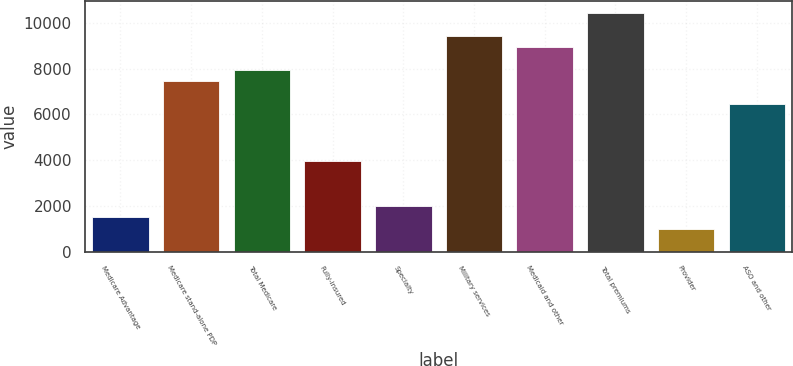Convert chart. <chart><loc_0><loc_0><loc_500><loc_500><bar_chart><fcel>Medicare Advantage<fcel>Medicare stand-alone PDP<fcel>Total Medicare<fcel>Fully-insured<fcel>Specialty<fcel>Military services<fcel>Medicaid and other<fcel>Total premiums<fcel>Provider<fcel>ASO and other<nl><fcel>1490.44<fcel>7448.56<fcel>7945.07<fcel>3972.99<fcel>1986.95<fcel>9434.6<fcel>8938.09<fcel>10427.6<fcel>993.93<fcel>6455.54<nl></chart> 